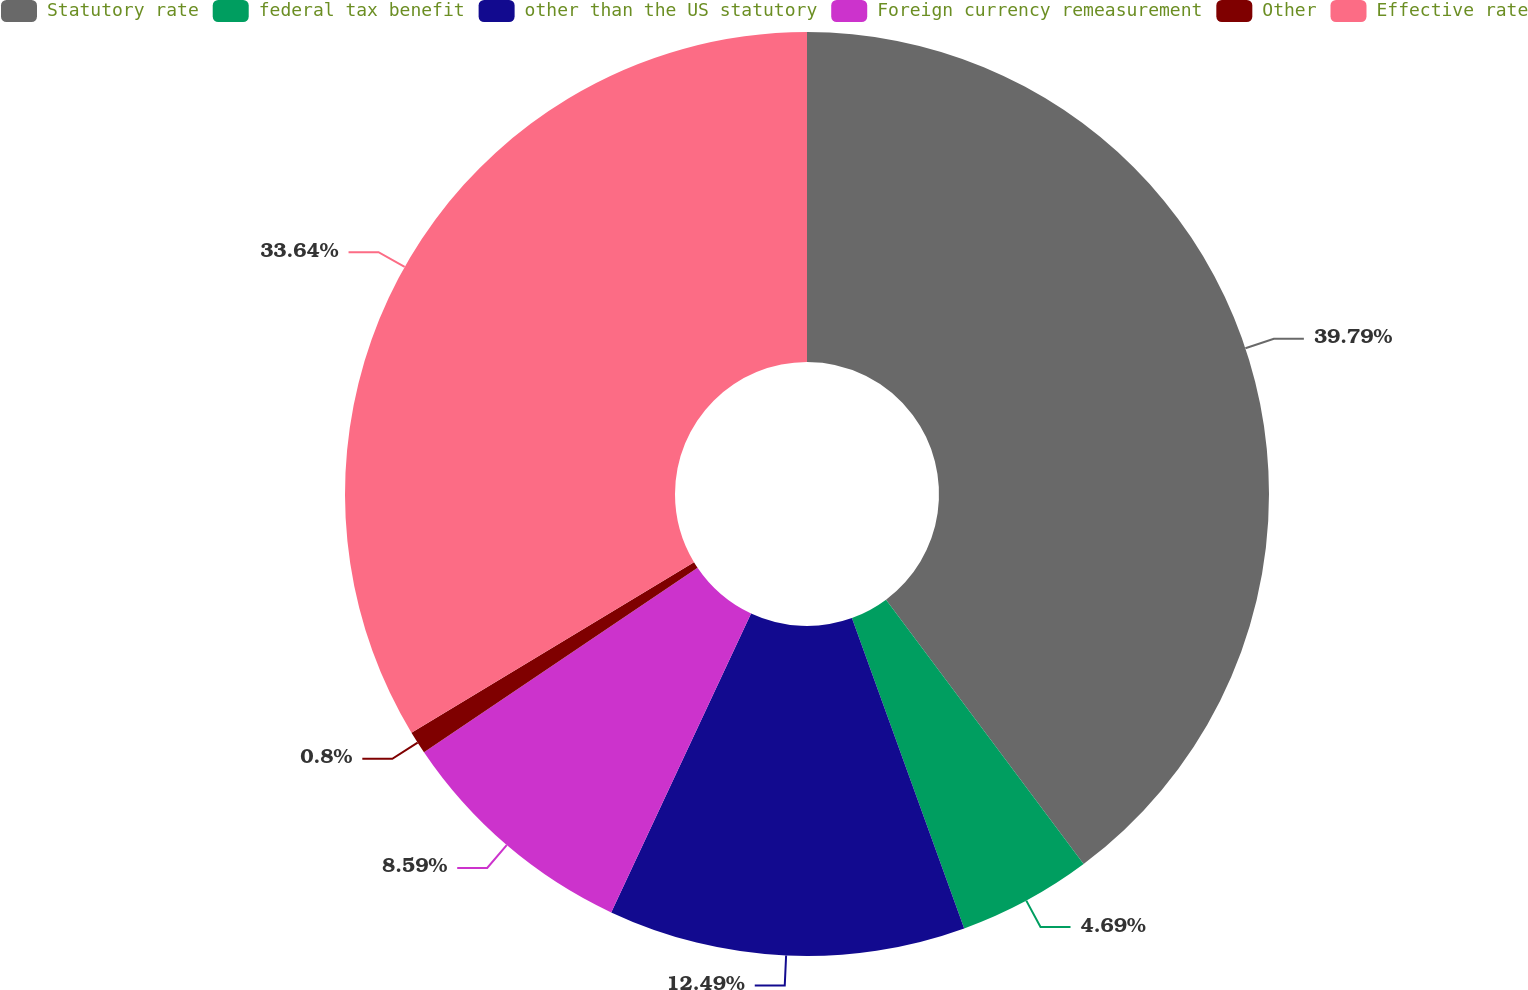Convert chart. <chart><loc_0><loc_0><loc_500><loc_500><pie_chart><fcel>Statutory rate<fcel>federal tax benefit<fcel>other than the US statutory<fcel>Foreign currency remeasurement<fcel>Other<fcel>Effective rate<nl><fcel>39.78%<fcel>4.69%<fcel>12.49%<fcel>8.59%<fcel>0.8%<fcel>33.64%<nl></chart> 